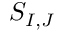Convert formula to latex. <formula><loc_0><loc_0><loc_500><loc_500>S _ { I , J }</formula> 